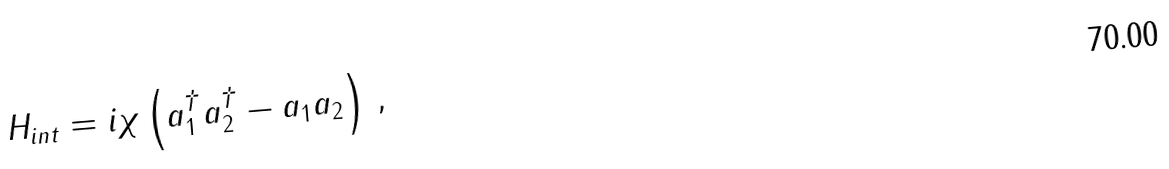<formula> <loc_0><loc_0><loc_500><loc_500>H _ { i n t } = i \chi \left ( a _ { 1 } ^ { \dag } a _ { 2 } ^ { \dag } - a _ { 1 } a _ { 2 } \right ) \, ,</formula> 